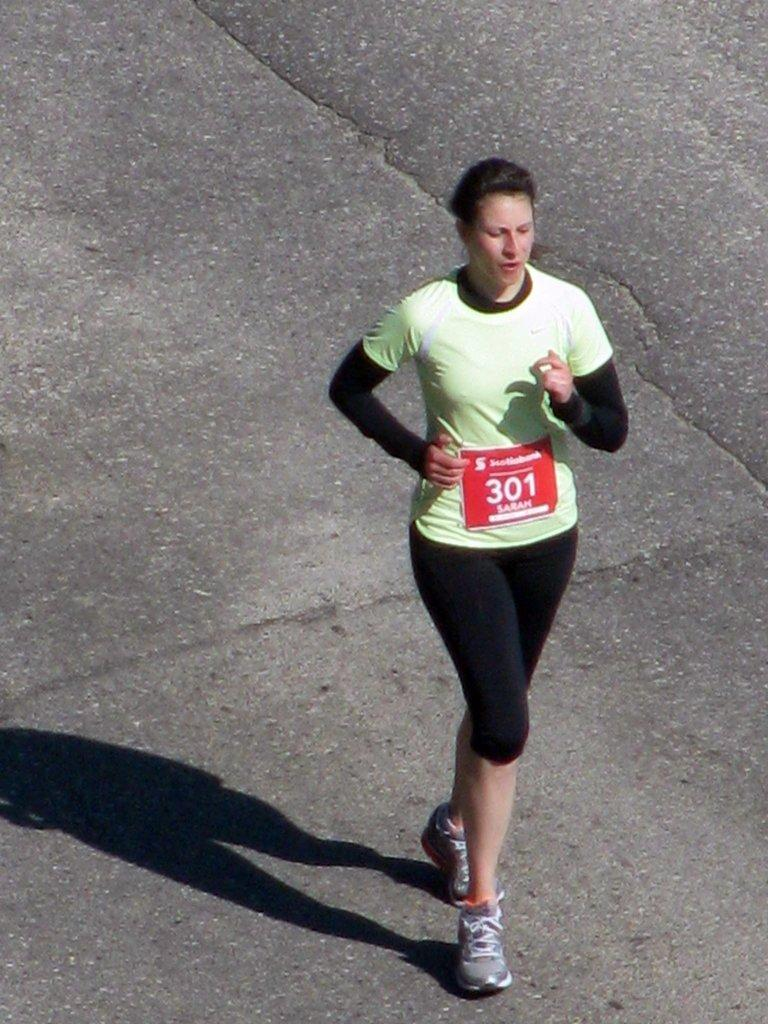Who is the main subject in the image? A: There is a woman in the image. What is the woman wearing? The woman is wearing a green t-shirt. What is the woman doing in the image? The woman is running. What type of apple can be seen in the woman's hand in the image? There is no apple present in the image; the woman is running and not holding any fruit. 